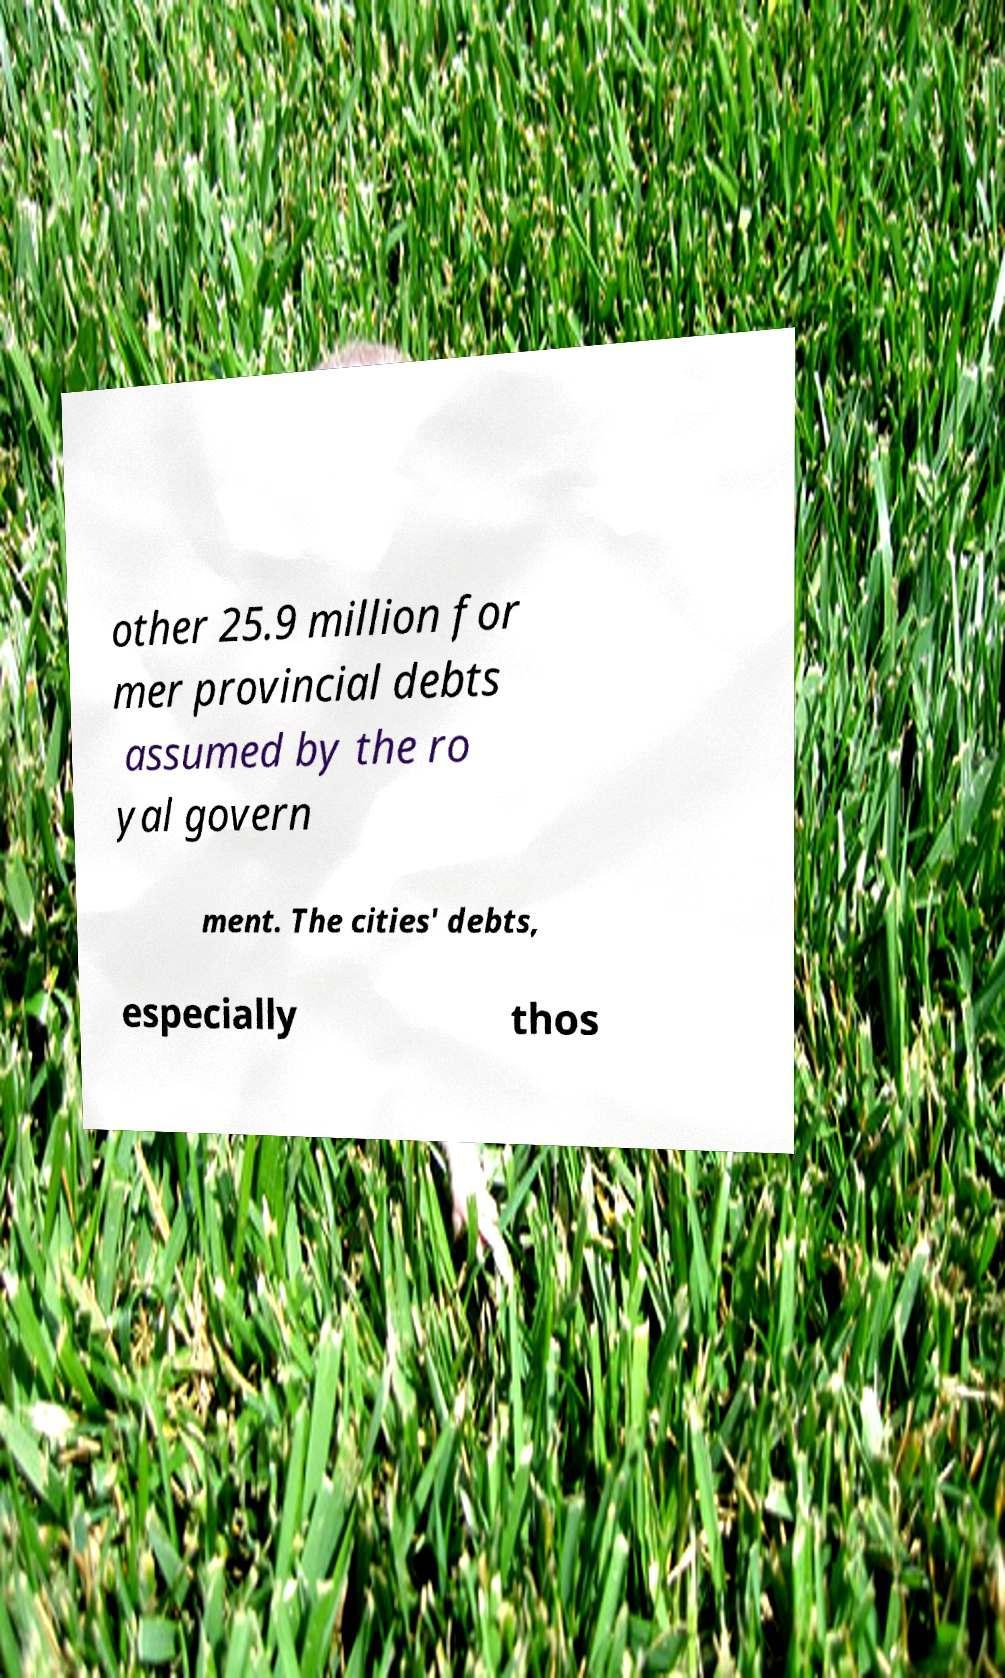For documentation purposes, I need the text within this image transcribed. Could you provide that? other 25.9 million for mer provincial debts assumed by the ro yal govern ment. The cities' debts, especially thos 